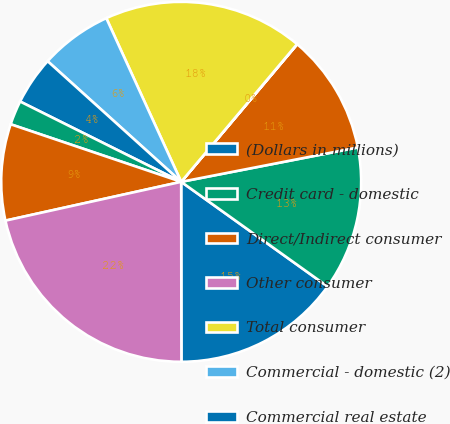Convert chart. <chart><loc_0><loc_0><loc_500><loc_500><pie_chart><fcel>(Dollars in millions)<fcel>Credit card - domestic<fcel>Direct/Indirect consumer<fcel>Other consumer<fcel>Total consumer<fcel>Commercial - domestic (2)<fcel>Commercial real estate<fcel>Commercial - foreign<fcel>Total commercial<fcel>Total accruing loans and<nl><fcel>15.1%<fcel>12.94%<fcel>10.79%<fcel>0.02%<fcel>17.96%<fcel>6.48%<fcel>4.33%<fcel>2.18%<fcel>8.64%<fcel>21.56%<nl></chart> 